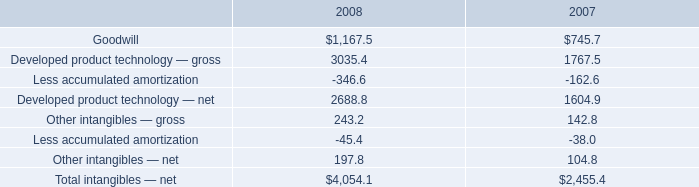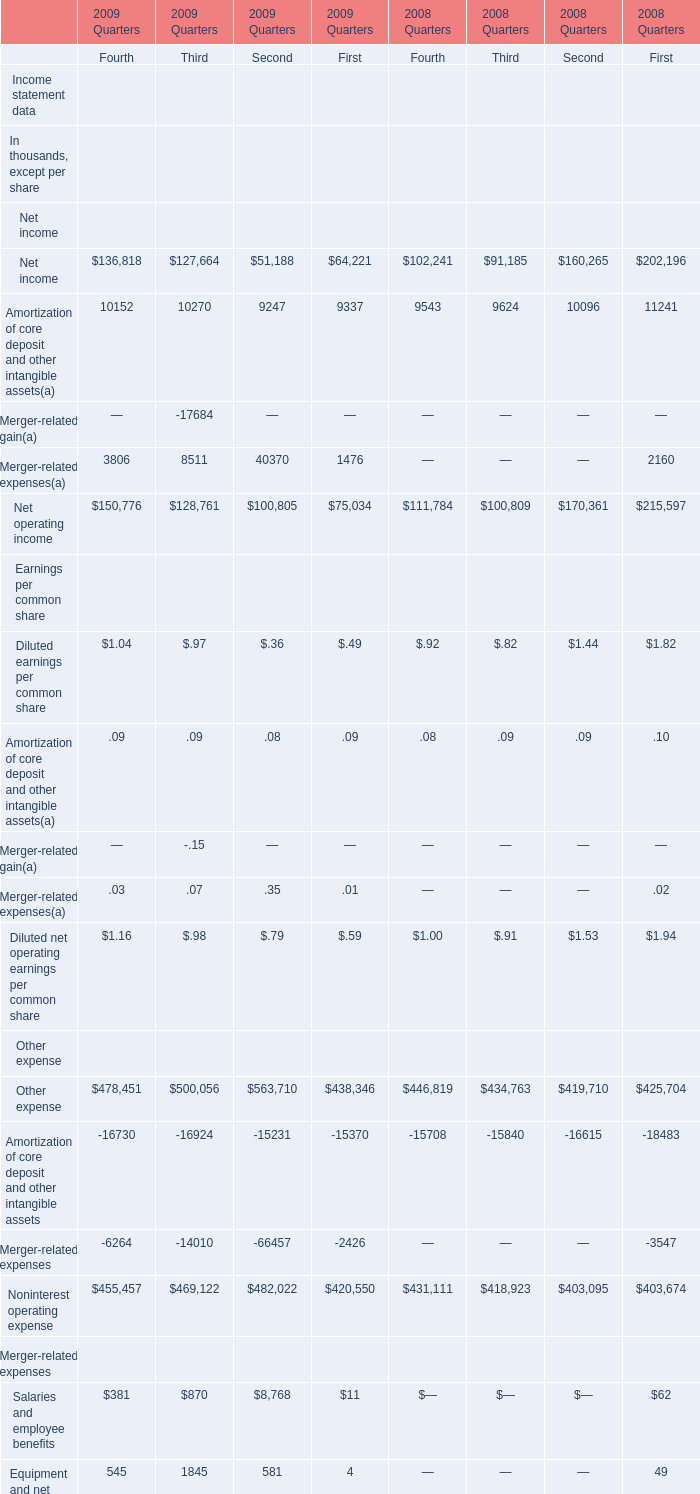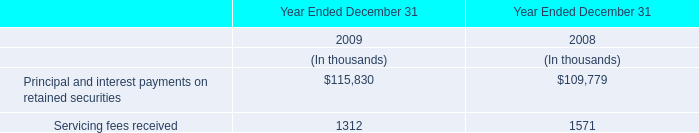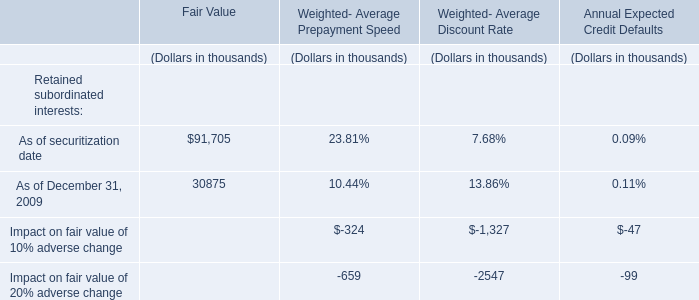what was the percent of growth or decline in the total intangibles 2014 net from 2007 to 2008 
Computations: ((4054.1 - 2455.4) / 2455.4)
Answer: 0.6511. 